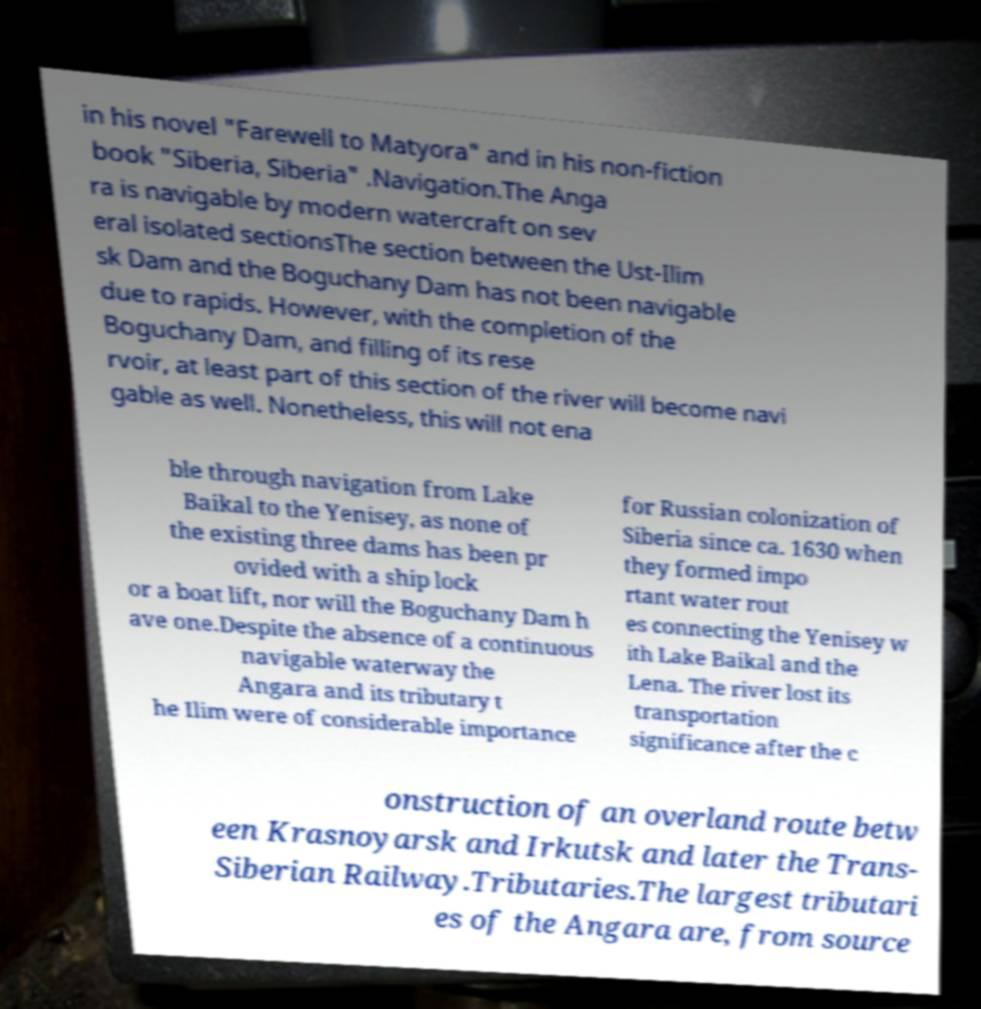What messages or text are displayed in this image? I need them in a readable, typed format. in his novel "Farewell to Matyora" and in his non-fiction book "Siberia, Siberia" .Navigation.The Anga ra is navigable by modern watercraft on sev eral isolated sectionsThe section between the Ust-Ilim sk Dam and the Boguchany Dam has not been navigable due to rapids. However, with the completion of the Boguchany Dam, and filling of its rese rvoir, at least part of this section of the river will become navi gable as well. Nonetheless, this will not ena ble through navigation from Lake Baikal to the Yenisey, as none of the existing three dams has been pr ovided with a ship lock or a boat lift, nor will the Boguchany Dam h ave one.Despite the absence of a continuous navigable waterway the Angara and its tributary t he Ilim were of considerable importance for Russian colonization of Siberia since ca. 1630 when they formed impo rtant water rout es connecting the Yenisey w ith Lake Baikal and the Lena. The river lost its transportation significance after the c onstruction of an overland route betw een Krasnoyarsk and Irkutsk and later the Trans- Siberian Railway.Tributaries.The largest tributari es of the Angara are, from source 